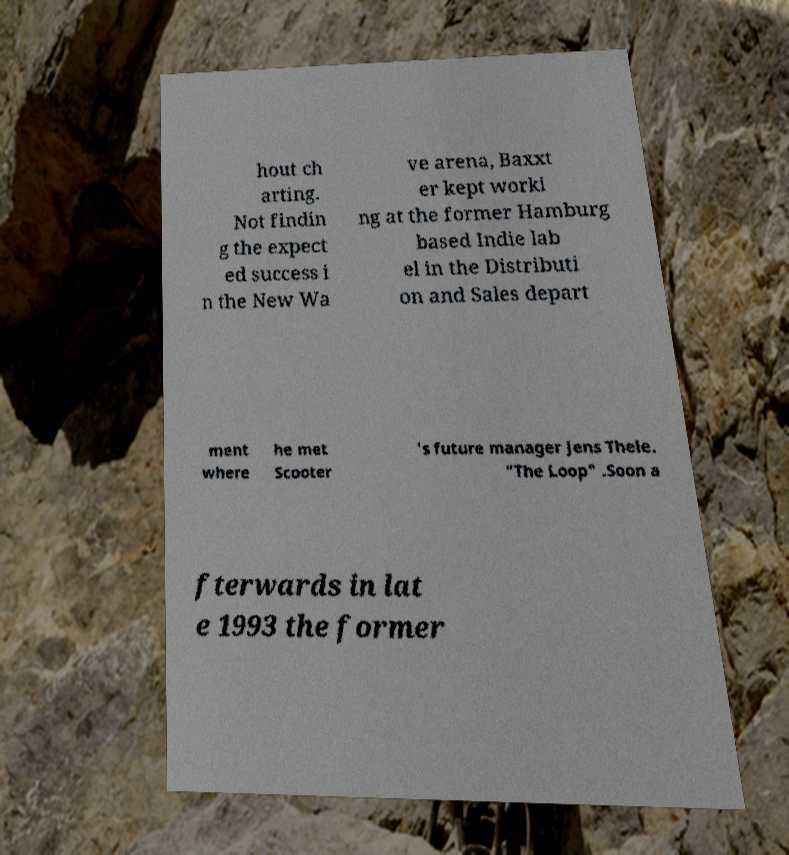Can you accurately transcribe the text from the provided image for me? hout ch arting. Not findin g the expect ed success i n the New Wa ve arena, Baxxt er kept worki ng at the former Hamburg based Indie lab el in the Distributi on and Sales depart ment where he met Scooter 's future manager Jens Thele. "The Loop" .Soon a fterwards in lat e 1993 the former 